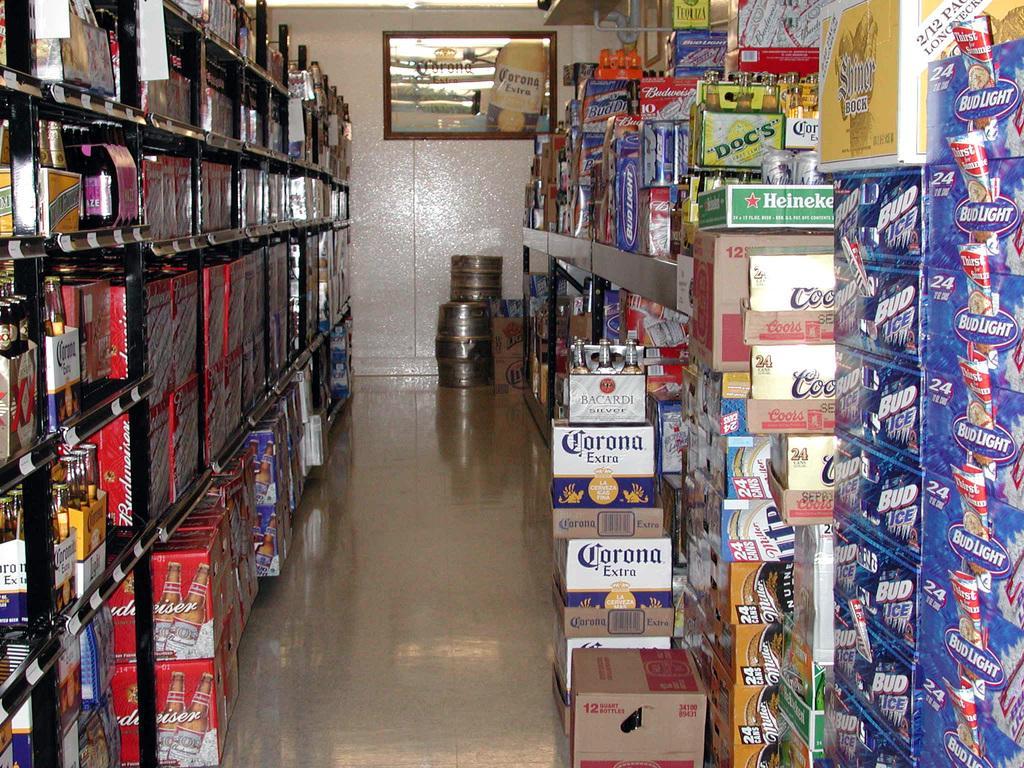Can you describe this image briefly? In this image I can see many colorful objects in the rack. To the side I can see the cardboard boxes. In the background I can see the containers and frames to the wall. 